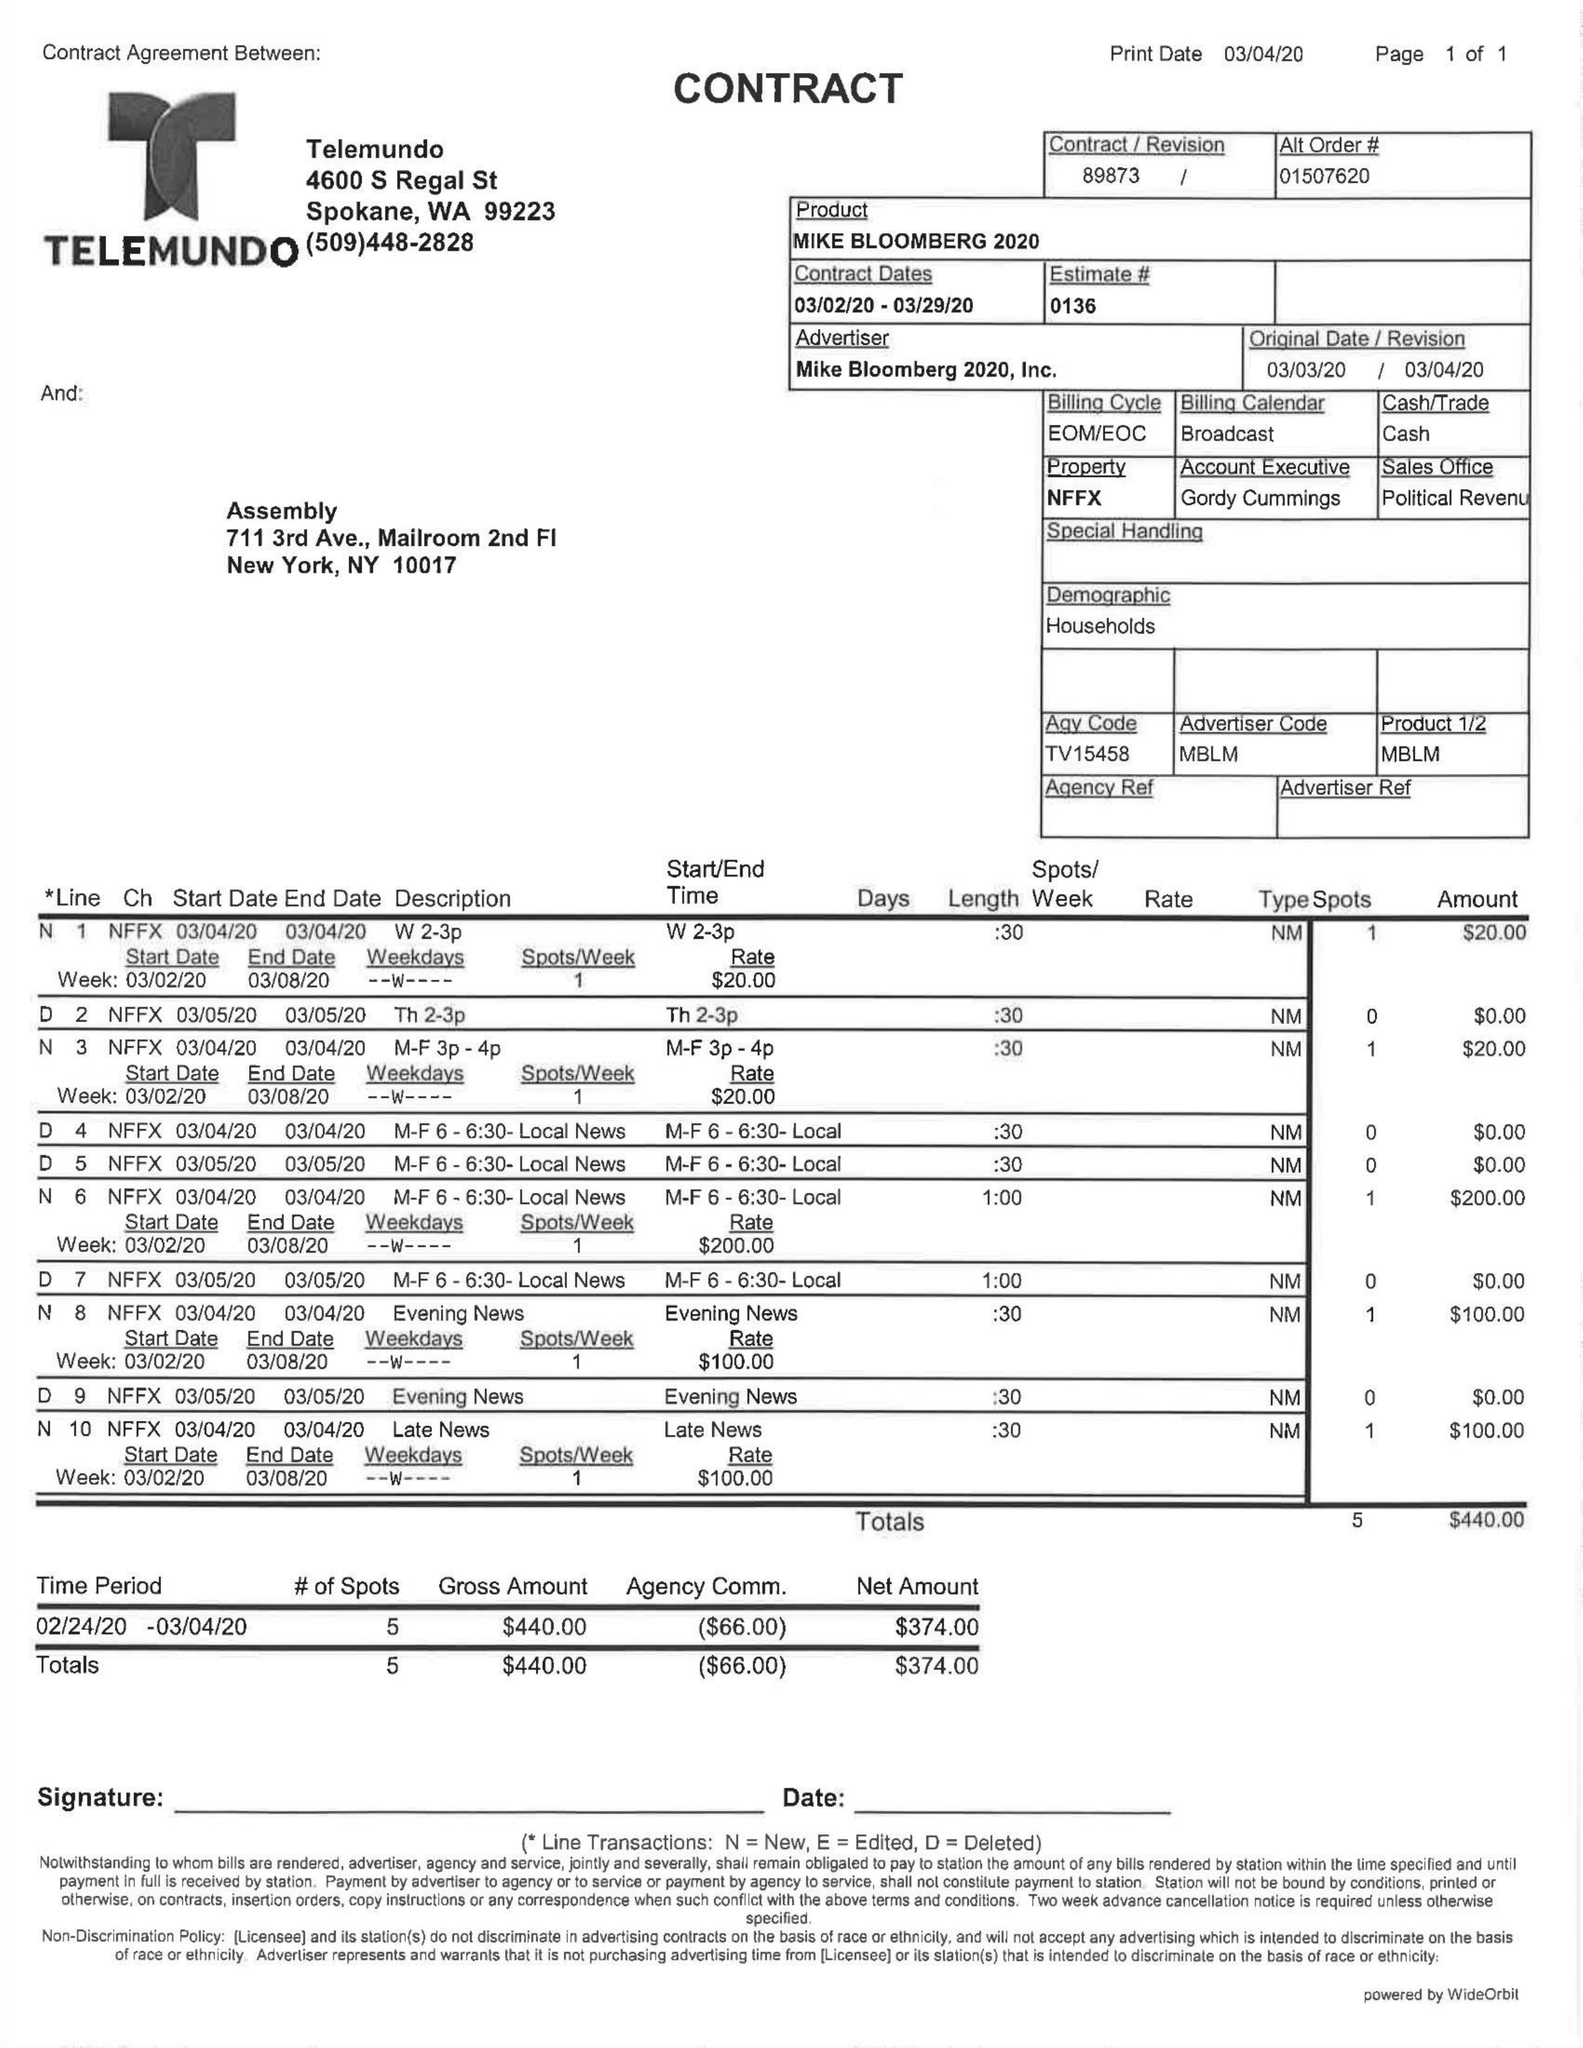What is the value for the contract_num?
Answer the question using a single word or phrase. 89873 